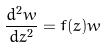Convert formula to latex. <formula><loc_0><loc_0><loc_500><loc_500>\frac { d ^ { 2 } w } { d z ^ { 2 } } = f ( z ) w</formula> 